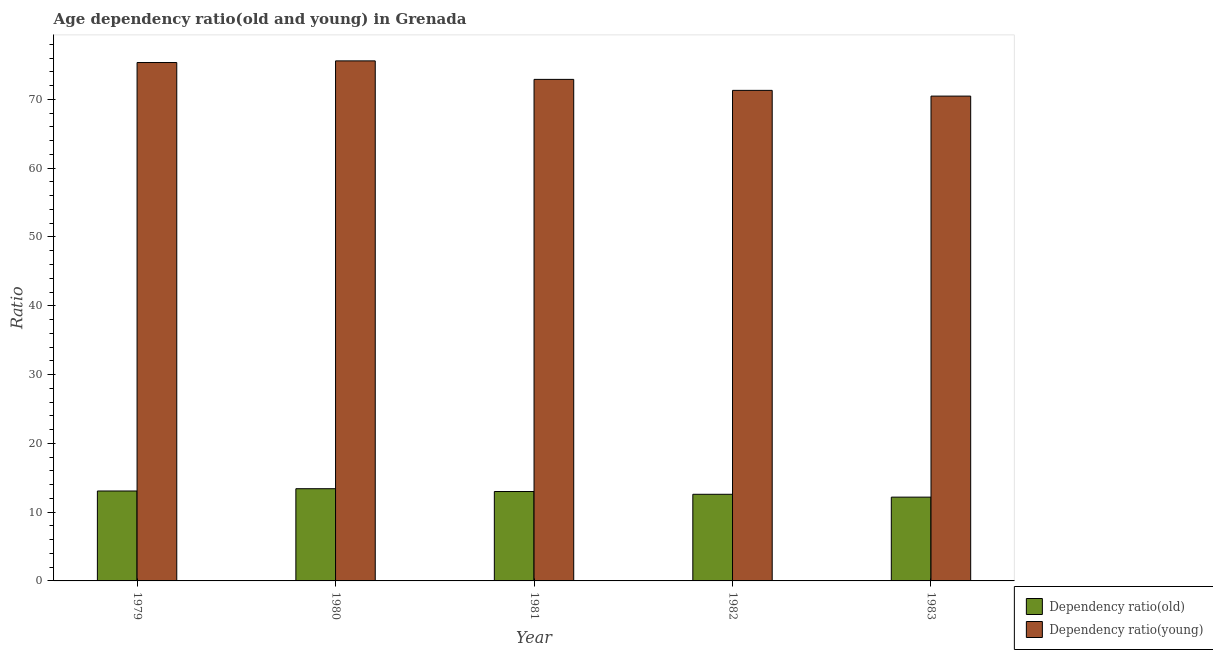How many groups of bars are there?
Offer a terse response. 5. Are the number of bars per tick equal to the number of legend labels?
Provide a short and direct response. Yes. Are the number of bars on each tick of the X-axis equal?
Ensure brevity in your answer.  Yes. How many bars are there on the 1st tick from the left?
Provide a short and direct response. 2. What is the label of the 4th group of bars from the left?
Give a very brief answer. 1982. What is the age dependency ratio(old) in 1983?
Ensure brevity in your answer.  12.18. Across all years, what is the maximum age dependency ratio(old)?
Your response must be concise. 13.41. Across all years, what is the minimum age dependency ratio(old)?
Offer a very short reply. 12.18. What is the total age dependency ratio(old) in the graph?
Your answer should be very brief. 64.25. What is the difference between the age dependency ratio(old) in 1979 and that in 1983?
Make the answer very short. 0.89. What is the difference between the age dependency ratio(old) in 1982 and the age dependency ratio(young) in 1983?
Ensure brevity in your answer.  0.41. What is the average age dependency ratio(old) per year?
Keep it short and to the point. 12.85. In the year 1982, what is the difference between the age dependency ratio(young) and age dependency ratio(old)?
Make the answer very short. 0. In how many years, is the age dependency ratio(old) greater than 42?
Keep it short and to the point. 0. What is the ratio of the age dependency ratio(young) in 1979 to that in 1981?
Offer a terse response. 1.03. Is the age dependency ratio(young) in 1979 less than that in 1982?
Give a very brief answer. No. What is the difference between the highest and the second highest age dependency ratio(old)?
Your answer should be very brief. 0.33. What is the difference between the highest and the lowest age dependency ratio(young)?
Provide a succinct answer. 5.12. Is the sum of the age dependency ratio(young) in 1979 and 1980 greater than the maximum age dependency ratio(old) across all years?
Provide a succinct answer. Yes. What does the 1st bar from the left in 1983 represents?
Offer a terse response. Dependency ratio(old). What does the 2nd bar from the right in 1981 represents?
Make the answer very short. Dependency ratio(old). How many years are there in the graph?
Your answer should be compact. 5. Are the values on the major ticks of Y-axis written in scientific E-notation?
Offer a terse response. No. Does the graph contain any zero values?
Make the answer very short. No. Where does the legend appear in the graph?
Make the answer very short. Bottom right. How are the legend labels stacked?
Provide a short and direct response. Vertical. What is the title of the graph?
Ensure brevity in your answer.  Age dependency ratio(old and young) in Grenada. What is the label or title of the Y-axis?
Ensure brevity in your answer.  Ratio. What is the Ratio of Dependency ratio(old) in 1979?
Give a very brief answer. 13.07. What is the Ratio in Dependency ratio(young) in 1979?
Keep it short and to the point. 75.36. What is the Ratio of Dependency ratio(old) in 1980?
Offer a terse response. 13.41. What is the Ratio in Dependency ratio(young) in 1980?
Your response must be concise. 75.6. What is the Ratio in Dependency ratio(old) in 1981?
Offer a terse response. 13. What is the Ratio of Dependency ratio(young) in 1981?
Your answer should be compact. 72.91. What is the Ratio in Dependency ratio(old) in 1982?
Offer a very short reply. 12.59. What is the Ratio of Dependency ratio(young) in 1982?
Offer a terse response. 71.31. What is the Ratio in Dependency ratio(old) in 1983?
Provide a short and direct response. 12.18. What is the Ratio of Dependency ratio(young) in 1983?
Keep it short and to the point. 70.48. Across all years, what is the maximum Ratio of Dependency ratio(old)?
Offer a very short reply. 13.41. Across all years, what is the maximum Ratio in Dependency ratio(young)?
Offer a very short reply. 75.6. Across all years, what is the minimum Ratio in Dependency ratio(old)?
Keep it short and to the point. 12.18. Across all years, what is the minimum Ratio of Dependency ratio(young)?
Provide a short and direct response. 70.48. What is the total Ratio of Dependency ratio(old) in the graph?
Your answer should be compact. 64.25. What is the total Ratio in Dependency ratio(young) in the graph?
Your answer should be compact. 365.67. What is the difference between the Ratio in Dependency ratio(old) in 1979 and that in 1980?
Offer a very short reply. -0.33. What is the difference between the Ratio in Dependency ratio(young) in 1979 and that in 1980?
Offer a very short reply. -0.24. What is the difference between the Ratio in Dependency ratio(old) in 1979 and that in 1981?
Give a very brief answer. 0.08. What is the difference between the Ratio of Dependency ratio(young) in 1979 and that in 1981?
Offer a terse response. 2.45. What is the difference between the Ratio of Dependency ratio(old) in 1979 and that in 1982?
Provide a short and direct response. 0.48. What is the difference between the Ratio in Dependency ratio(young) in 1979 and that in 1982?
Provide a succinct answer. 4.05. What is the difference between the Ratio of Dependency ratio(old) in 1979 and that in 1983?
Your response must be concise. 0.89. What is the difference between the Ratio in Dependency ratio(young) in 1979 and that in 1983?
Your answer should be compact. 4.88. What is the difference between the Ratio in Dependency ratio(old) in 1980 and that in 1981?
Give a very brief answer. 0.41. What is the difference between the Ratio of Dependency ratio(young) in 1980 and that in 1981?
Provide a succinct answer. 2.69. What is the difference between the Ratio in Dependency ratio(old) in 1980 and that in 1982?
Offer a very short reply. 0.81. What is the difference between the Ratio of Dependency ratio(young) in 1980 and that in 1982?
Your response must be concise. 4.29. What is the difference between the Ratio of Dependency ratio(old) in 1980 and that in 1983?
Ensure brevity in your answer.  1.23. What is the difference between the Ratio in Dependency ratio(young) in 1980 and that in 1983?
Make the answer very short. 5.12. What is the difference between the Ratio in Dependency ratio(old) in 1981 and that in 1982?
Your response must be concise. 0.4. What is the difference between the Ratio of Dependency ratio(young) in 1981 and that in 1982?
Your answer should be compact. 1.6. What is the difference between the Ratio in Dependency ratio(old) in 1981 and that in 1983?
Offer a very short reply. 0.82. What is the difference between the Ratio of Dependency ratio(young) in 1981 and that in 1983?
Your response must be concise. 2.43. What is the difference between the Ratio of Dependency ratio(old) in 1982 and that in 1983?
Your response must be concise. 0.41. What is the difference between the Ratio in Dependency ratio(young) in 1982 and that in 1983?
Offer a very short reply. 0.83. What is the difference between the Ratio of Dependency ratio(old) in 1979 and the Ratio of Dependency ratio(young) in 1980?
Give a very brief answer. -62.53. What is the difference between the Ratio of Dependency ratio(old) in 1979 and the Ratio of Dependency ratio(young) in 1981?
Your answer should be compact. -59.84. What is the difference between the Ratio of Dependency ratio(old) in 1979 and the Ratio of Dependency ratio(young) in 1982?
Give a very brief answer. -58.24. What is the difference between the Ratio in Dependency ratio(old) in 1979 and the Ratio in Dependency ratio(young) in 1983?
Offer a terse response. -57.41. What is the difference between the Ratio in Dependency ratio(old) in 1980 and the Ratio in Dependency ratio(young) in 1981?
Provide a short and direct response. -59.51. What is the difference between the Ratio in Dependency ratio(old) in 1980 and the Ratio in Dependency ratio(young) in 1982?
Give a very brief answer. -57.91. What is the difference between the Ratio of Dependency ratio(old) in 1980 and the Ratio of Dependency ratio(young) in 1983?
Give a very brief answer. -57.07. What is the difference between the Ratio in Dependency ratio(old) in 1981 and the Ratio in Dependency ratio(young) in 1982?
Provide a succinct answer. -58.32. What is the difference between the Ratio in Dependency ratio(old) in 1981 and the Ratio in Dependency ratio(young) in 1983?
Provide a succinct answer. -57.48. What is the difference between the Ratio in Dependency ratio(old) in 1982 and the Ratio in Dependency ratio(young) in 1983?
Give a very brief answer. -57.89. What is the average Ratio of Dependency ratio(old) per year?
Provide a short and direct response. 12.85. What is the average Ratio of Dependency ratio(young) per year?
Your answer should be compact. 73.13. In the year 1979, what is the difference between the Ratio of Dependency ratio(old) and Ratio of Dependency ratio(young)?
Ensure brevity in your answer.  -62.29. In the year 1980, what is the difference between the Ratio of Dependency ratio(old) and Ratio of Dependency ratio(young)?
Give a very brief answer. -62.2. In the year 1981, what is the difference between the Ratio in Dependency ratio(old) and Ratio in Dependency ratio(young)?
Keep it short and to the point. -59.92. In the year 1982, what is the difference between the Ratio of Dependency ratio(old) and Ratio of Dependency ratio(young)?
Your response must be concise. -58.72. In the year 1983, what is the difference between the Ratio of Dependency ratio(old) and Ratio of Dependency ratio(young)?
Provide a short and direct response. -58.3. What is the ratio of the Ratio in Dependency ratio(old) in 1979 to that in 1980?
Your answer should be very brief. 0.98. What is the ratio of the Ratio in Dependency ratio(old) in 1979 to that in 1981?
Provide a short and direct response. 1.01. What is the ratio of the Ratio in Dependency ratio(young) in 1979 to that in 1981?
Offer a terse response. 1.03. What is the ratio of the Ratio of Dependency ratio(old) in 1979 to that in 1982?
Offer a terse response. 1.04. What is the ratio of the Ratio in Dependency ratio(young) in 1979 to that in 1982?
Your answer should be very brief. 1.06. What is the ratio of the Ratio in Dependency ratio(old) in 1979 to that in 1983?
Your answer should be compact. 1.07. What is the ratio of the Ratio of Dependency ratio(young) in 1979 to that in 1983?
Your answer should be compact. 1.07. What is the ratio of the Ratio of Dependency ratio(old) in 1980 to that in 1981?
Provide a succinct answer. 1.03. What is the ratio of the Ratio of Dependency ratio(young) in 1980 to that in 1981?
Your response must be concise. 1.04. What is the ratio of the Ratio of Dependency ratio(old) in 1980 to that in 1982?
Your answer should be very brief. 1.06. What is the ratio of the Ratio of Dependency ratio(young) in 1980 to that in 1982?
Provide a succinct answer. 1.06. What is the ratio of the Ratio of Dependency ratio(old) in 1980 to that in 1983?
Make the answer very short. 1.1. What is the ratio of the Ratio of Dependency ratio(young) in 1980 to that in 1983?
Provide a succinct answer. 1.07. What is the ratio of the Ratio in Dependency ratio(old) in 1981 to that in 1982?
Give a very brief answer. 1.03. What is the ratio of the Ratio in Dependency ratio(young) in 1981 to that in 1982?
Your answer should be compact. 1.02. What is the ratio of the Ratio of Dependency ratio(old) in 1981 to that in 1983?
Offer a very short reply. 1.07. What is the ratio of the Ratio of Dependency ratio(young) in 1981 to that in 1983?
Your answer should be compact. 1.03. What is the ratio of the Ratio of Dependency ratio(old) in 1982 to that in 1983?
Give a very brief answer. 1.03. What is the ratio of the Ratio of Dependency ratio(young) in 1982 to that in 1983?
Provide a short and direct response. 1.01. What is the difference between the highest and the second highest Ratio of Dependency ratio(old)?
Provide a short and direct response. 0.33. What is the difference between the highest and the second highest Ratio in Dependency ratio(young)?
Keep it short and to the point. 0.24. What is the difference between the highest and the lowest Ratio in Dependency ratio(old)?
Keep it short and to the point. 1.23. What is the difference between the highest and the lowest Ratio in Dependency ratio(young)?
Make the answer very short. 5.12. 